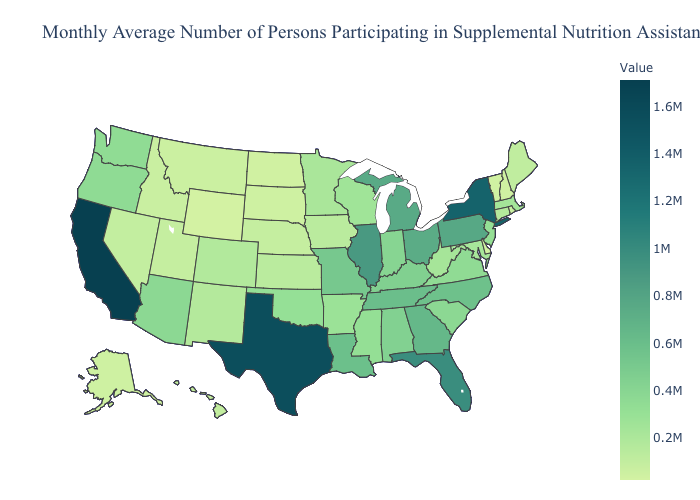Does Kansas have the highest value in the MidWest?
Short answer required. No. Does Louisiana have the lowest value in the USA?
Concise answer only. No. Among the states that border Minnesota , which have the highest value?
Quick response, please. Wisconsin. Which states have the lowest value in the USA?
Give a very brief answer. Wyoming. Does Florida have a lower value than Rhode Island?
Quick response, please. No. Which states have the lowest value in the South?
Keep it brief. Delaware. 